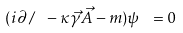Convert formula to latex. <formula><loc_0><loc_0><loc_500><loc_500>( i { \partial \, / \ } - \kappa { \vec { \gamma } } { \vec { A } } - m ) \psi \ = 0</formula> 